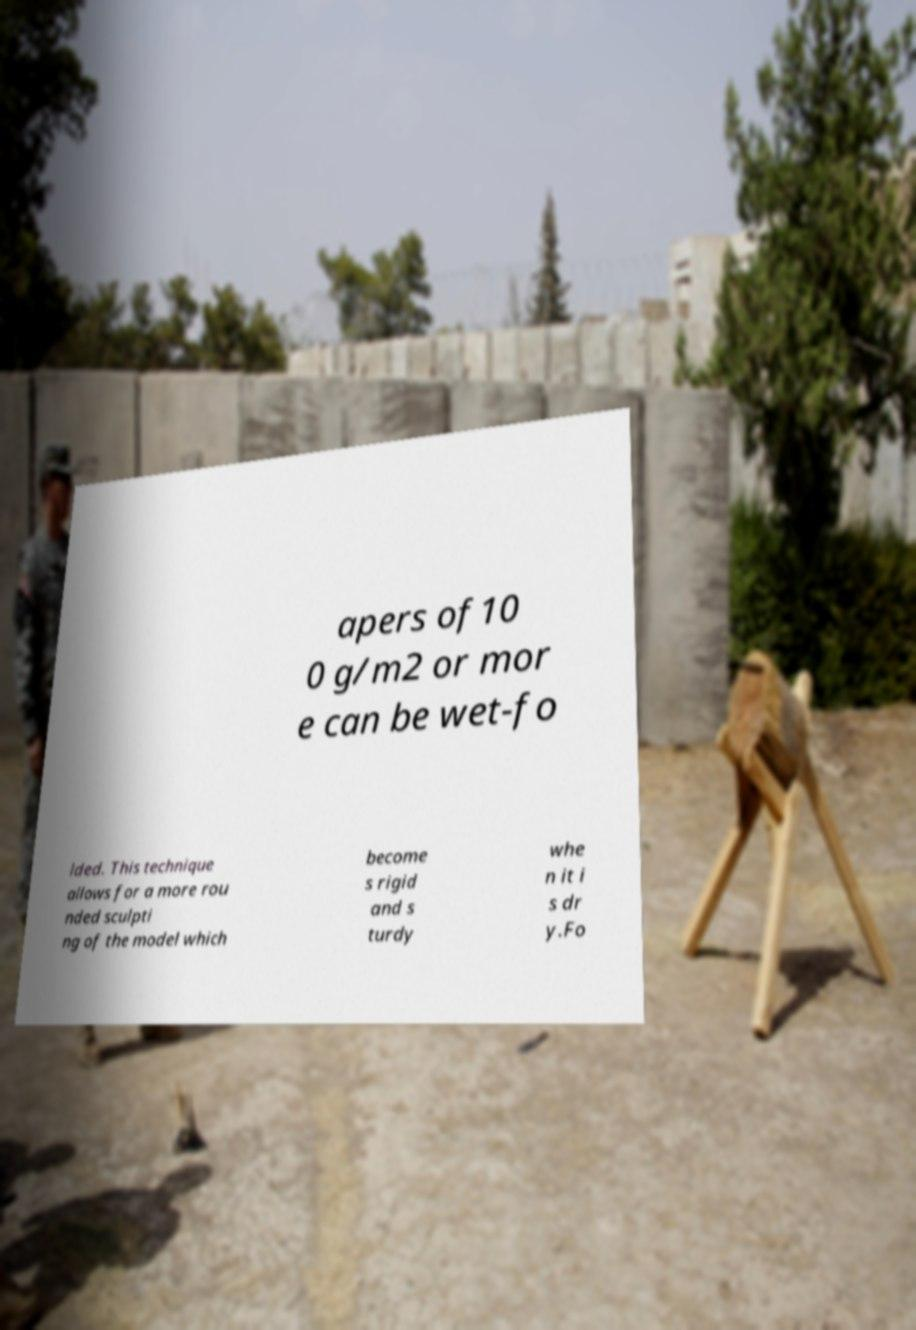Please identify and transcribe the text found in this image. apers of10 0 g/m2 or mor e can be wet-fo lded. This technique allows for a more rou nded sculpti ng of the model which become s rigid and s turdy whe n it i s dr y.Fo 